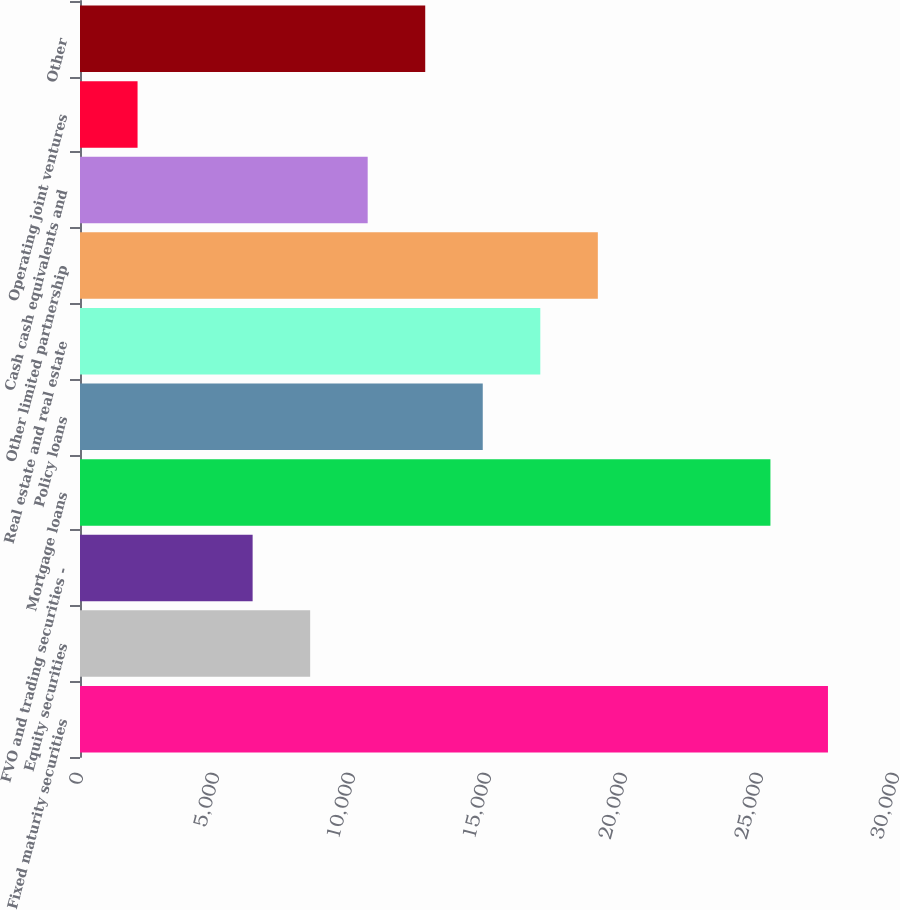Convert chart to OTSL. <chart><loc_0><loc_0><loc_500><loc_500><bar_chart><fcel>Fixed maturity securities<fcel>Equity securities<fcel>FVO and trading securities -<fcel>Mortgage loans<fcel>Policy loans<fcel>Real estate and real estate<fcel>Other limited partnership<fcel>Cash cash equivalents and<fcel>Operating joint ventures<fcel>Other<nl><fcel>27498.6<fcel>8461.8<fcel>6346.6<fcel>25383.4<fcel>14807.4<fcel>16922.6<fcel>19037.8<fcel>10577<fcel>2116.2<fcel>12692.2<nl></chart> 